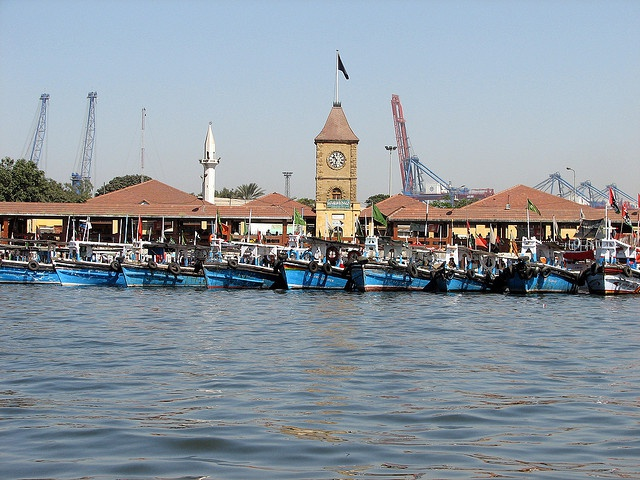Describe the objects in this image and their specific colors. I can see boat in lightblue, black, gray, white, and darkgray tones, boat in lightblue, black, gray, white, and navy tones, boat in lightblue, black, gray, white, and darkgray tones, boat in lightblue, black, white, gray, and navy tones, and boat in lightblue, black, gray, blue, and white tones in this image. 